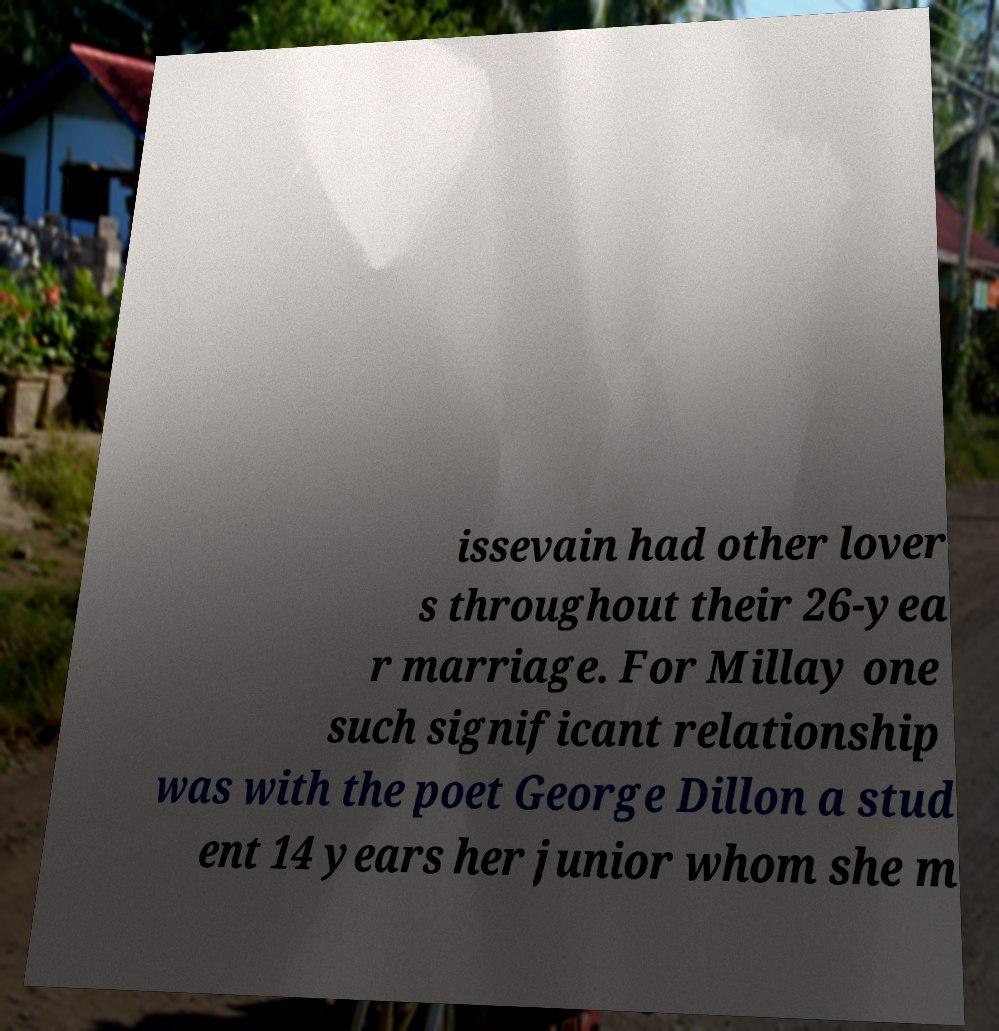There's text embedded in this image that I need extracted. Can you transcribe it verbatim? issevain had other lover s throughout their 26-yea r marriage. For Millay one such significant relationship was with the poet George Dillon a stud ent 14 years her junior whom she m 